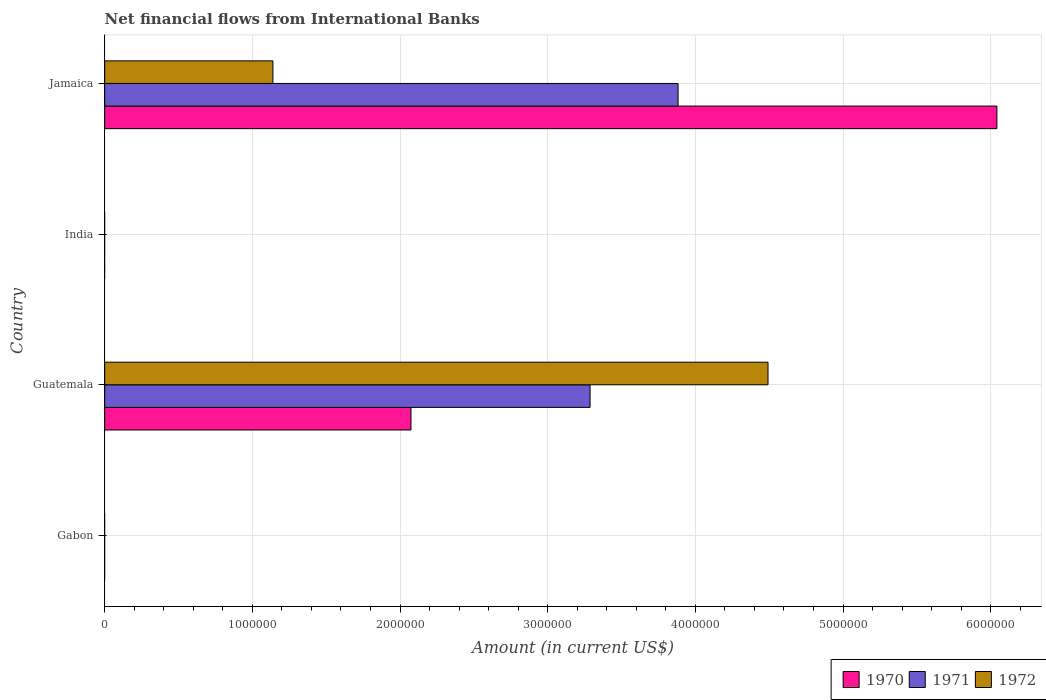How many different coloured bars are there?
Offer a very short reply. 3. Are the number of bars per tick equal to the number of legend labels?
Provide a short and direct response. No. Are the number of bars on each tick of the Y-axis equal?
Your answer should be compact. No. Across all countries, what is the maximum net financial aid flows in 1972?
Make the answer very short. 4.49e+06. In which country was the net financial aid flows in 1970 maximum?
Your answer should be very brief. Jamaica. What is the total net financial aid flows in 1970 in the graph?
Ensure brevity in your answer.  8.12e+06. What is the difference between the net financial aid flows in 1970 in Guatemala and that in Jamaica?
Make the answer very short. -3.97e+06. What is the difference between the net financial aid flows in 1971 in Guatemala and the net financial aid flows in 1970 in India?
Your response must be concise. 3.29e+06. What is the average net financial aid flows in 1972 per country?
Your response must be concise. 1.41e+06. What is the difference between the net financial aid flows in 1970 and net financial aid flows in 1971 in Guatemala?
Provide a succinct answer. -1.21e+06. In how many countries, is the net financial aid flows in 1970 greater than 3000000 US$?
Offer a terse response. 1. What is the ratio of the net financial aid flows in 1970 in Guatemala to that in Jamaica?
Your response must be concise. 0.34. Is the difference between the net financial aid flows in 1970 in Guatemala and Jamaica greater than the difference between the net financial aid flows in 1971 in Guatemala and Jamaica?
Make the answer very short. No. What is the difference between the highest and the lowest net financial aid flows in 1972?
Keep it short and to the point. 4.49e+06. In how many countries, is the net financial aid flows in 1971 greater than the average net financial aid flows in 1971 taken over all countries?
Your answer should be compact. 2. How many bars are there?
Ensure brevity in your answer.  6. How many countries are there in the graph?
Ensure brevity in your answer.  4. What is the difference between two consecutive major ticks on the X-axis?
Your response must be concise. 1.00e+06. Are the values on the major ticks of X-axis written in scientific E-notation?
Offer a terse response. No. Does the graph contain grids?
Provide a short and direct response. Yes. Where does the legend appear in the graph?
Offer a very short reply. Bottom right. How are the legend labels stacked?
Provide a short and direct response. Horizontal. What is the title of the graph?
Provide a succinct answer. Net financial flows from International Banks. Does "2005" appear as one of the legend labels in the graph?
Ensure brevity in your answer.  No. What is the Amount (in current US$) of 1970 in Gabon?
Your response must be concise. 0. What is the Amount (in current US$) of 1972 in Gabon?
Keep it short and to the point. 0. What is the Amount (in current US$) in 1970 in Guatemala?
Offer a terse response. 2.07e+06. What is the Amount (in current US$) in 1971 in Guatemala?
Your answer should be very brief. 3.29e+06. What is the Amount (in current US$) of 1972 in Guatemala?
Your answer should be very brief. 4.49e+06. What is the Amount (in current US$) in 1971 in India?
Your answer should be compact. 0. What is the Amount (in current US$) of 1972 in India?
Offer a terse response. 0. What is the Amount (in current US$) of 1970 in Jamaica?
Provide a short and direct response. 6.04e+06. What is the Amount (in current US$) in 1971 in Jamaica?
Keep it short and to the point. 3.88e+06. What is the Amount (in current US$) of 1972 in Jamaica?
Give a very brief answer. 1.14e+06. Across all countries, what is the maximum Amount (in current US$) of 1970?
Your answer should be very brief. 6.04e+06. Across all countries, what is the maximum Amount (in current US$) of 1971?
Provide a short and direct response. 3.88e+06. Across all countries, what is the maximum Amount (in current US$) in 1972?
Make the answer very short. 4.49e+06. Across all countries, what is the minimum Amount (in current US$) of 1971?
Keep it short and to the point. 0. Across all countries, what is the minimum Amount (in current US$) of 1972?
Offer a terse response. 0. What is the total Amount (in current US$) in 1970 in the graph?
Provide a succinct answer. 8.12e+06. What is the total Amount (in current US$) in 1971 in the graph?
Keep it short and to the point. 7.17e+06. What is the total Amount (in current US$) in 1972 in the graph?
Your response must be concise. 5.63e+06. What is the difference between the Amount (in current US$) in 1970 in Guatemala and that in Jamaica?
Your answer should be very brief. -3.97e+06. What is the difference between the Amount (in current US$) of 1971 in Guatemala and that in Jamaica?
Your response must be concise. -5.96e+05. What is the difference between the Amount (in current US$) of 1972 in Guatemala and that in Jamaica?
Keep it short and to the point. 3.35e+06. What is the difference between the Amount (in current US$) in 1970 in Guatemala and the Amount (in current US$) in 1971 in Jamaica?
Provide a short and direct response. -1.81e+06. What is the difference between the Amount (in current US$) of 1970 in Guatemala and the Amount (in current US$) of 1972 in Jamaica?
Offer a very short reply. 9.35e+05. What is the difference between the Amount (in current US$) in 1971 in Guatemala and the Amount (in current US$) in 1972 in Jamaica?
Offer a very short reply. 2.15e+06. What is the average Amount (in current US$) in 1970 per country?
Provide a succinct answer. 2.03e+06. What is the average Amount (in current US$) of 1971 per country?
Make the answer very short. 1.79e+06. What is the average Amount (in current US$) of 1972 per country?
Offer a terse response. 1.41e+06. What is the difference between the Amount (in current US$) of 1970 and Amount (in current US$) of 1971 in Guatemala?
Give a very brief answer. -1.21e+06. What is the difference between the Amount (in current US$) of 1970 and Amount (in current US$) of 1972 in Guatemala?
Offer a terse response. -2.42e+06. What is the difference between the Amount (in current US$) in 1971 and Amount (in current US$) in 1972 in Guatemala?
Ensure brevity in your answer.  -1.20e+06. What is the difference between the Amount (in current US$) of 1970 and Amount (in current US$) of 1971 in Jamaica?
Your answer should be very brief. 2.16e+06. What is the difference between the Amount (in current US$) in 1970 and Amount (in current US$) in 1972 in Jamaica?
Make the answer very short. 4.90e+06. What is the difference between the Amount (in current US$) in 1971 and Amount (in current US$) in 1972 in Jamaica?
Offer a terse response. 2.74e+06. What is the ratio of the Amount (in current US$) of 1970 in Guatemala to that in Jamaica?
Keep it short and to the point. 0.34. What is the ratio of the Amount (in current US$) in 1971 in Guatemala to that in Jamaica?
Your response must be concise. 0.85. What is the ratio of the Amount (in current US$) of 1972 in Guatemala to that in Jamaica?
Offer a terse response. 3.94. What is the difference between the highest and the lowest Amount (in current US$) of 1970?
Offer a very short reply. 6.04e+06. What is the difference between the highest and the lowest Amount (in current US$) in 1971?
Your answer should be compact. 3.88e+06. What is the difference between the highest and the lowest Amount (in current US$) of 1972?
Your response must be concise. 4.49e+06. 